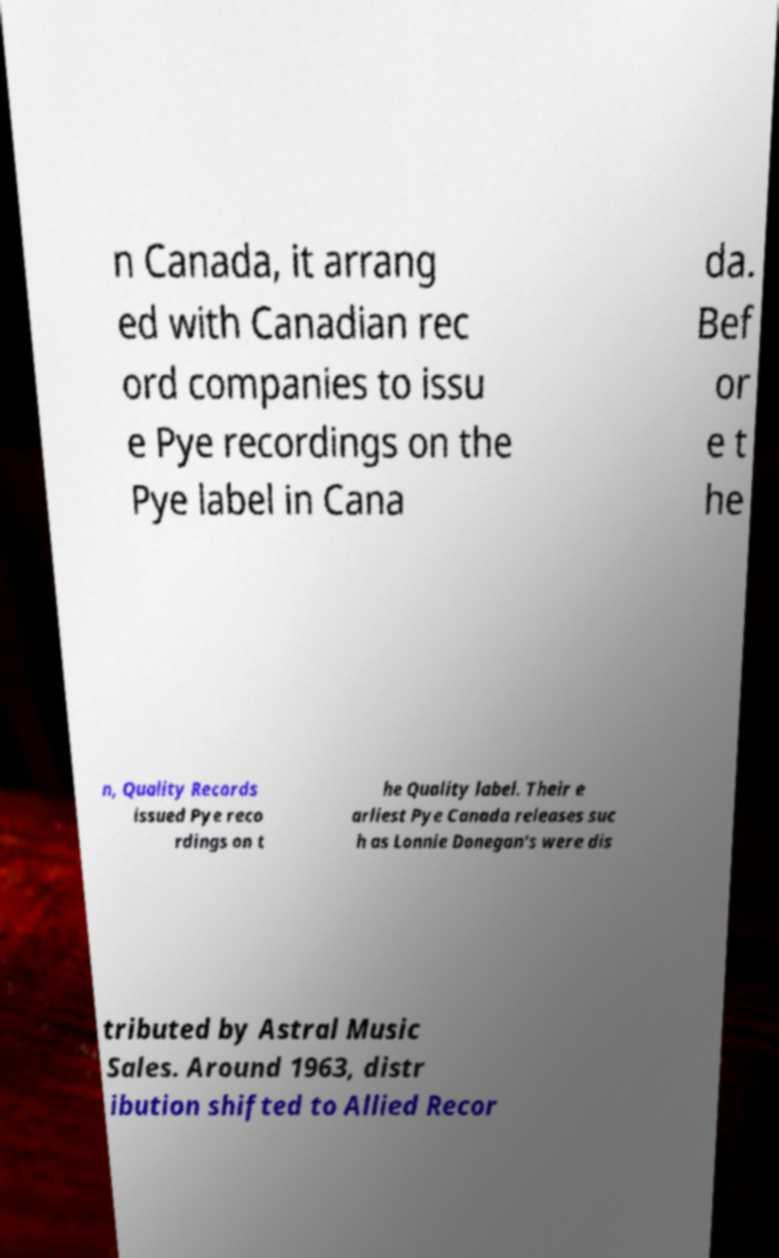Could you assist in decoding the text presented in this image and type it out clearly? n Canada, it arrang ed with Canadian rec ord companies to issu e Pye recordings on the Pye label in Cana da. Bef or e t he n, Quality Records issued Pye reco rdings on t he Quality label. Their e arliest Pye Canada releases suc h as Lonnie Donegan's were dis tributed by Astral Music Sales. Around 1963, distr ibution shifted to Allied Recor 